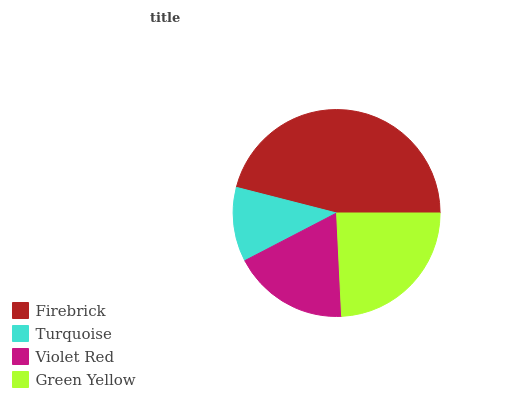Is Turquoise the minimum?
Answer yes or no. Yes. Is Firebrick the maximum?
Answer yes or no. Yes. Is Violet Red the minimum?
Answer yes or no. No. Is Violet Red the maximum?
Answer yes or no. No. Is Violet Red greater than Turquoise?
Answer yes or no. Yes. Is Turquoise less than Violet Red?
Answer yes or no. Yes. Is Turquoise greater than Violet Red?
Answer yes or no. No. Is Violet Red less than Turquoise?
Answer yes or no. No. Is Green Yellow the high median?
Answer yes or no. Yes. Is Violet Red the low median?
Answer yes or no. Yes. Is Firebrick the high median?
Answer yes or no. No. Is Green Yellow the low median?
Answer yes or no. No. 